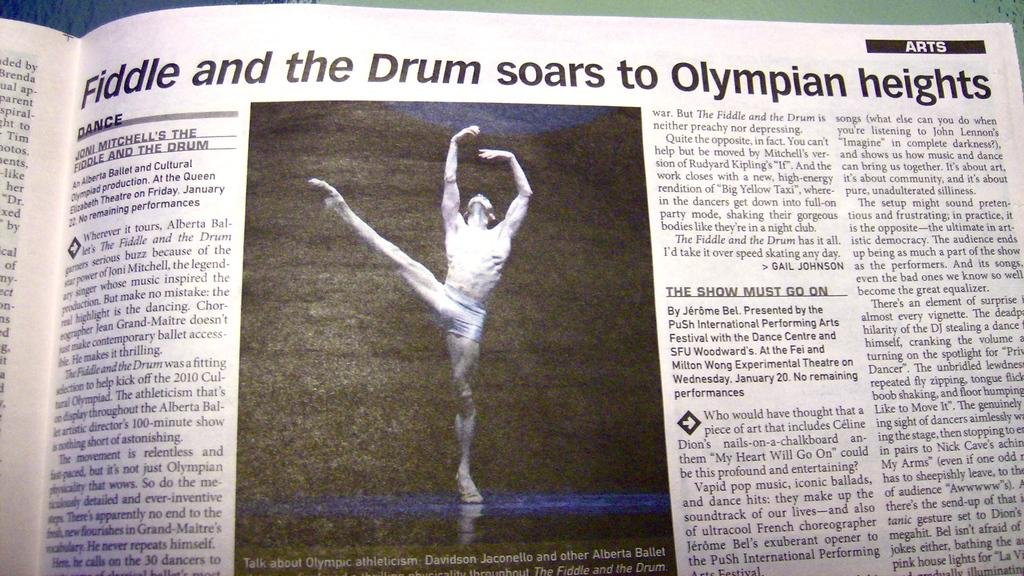What is present in the image that is made of paper? There is a paper in the image. What is depicted on the paper? The paper has a picture of a person printed on it. Are there any words or symbols on the paper? Yes, there is text on the paper. What type of bubble is floating near the paper in the image? There is no bubble present in the image. Is there a toy visible on the paper in the image? No, there is no toy depicted on the paper in the image. 